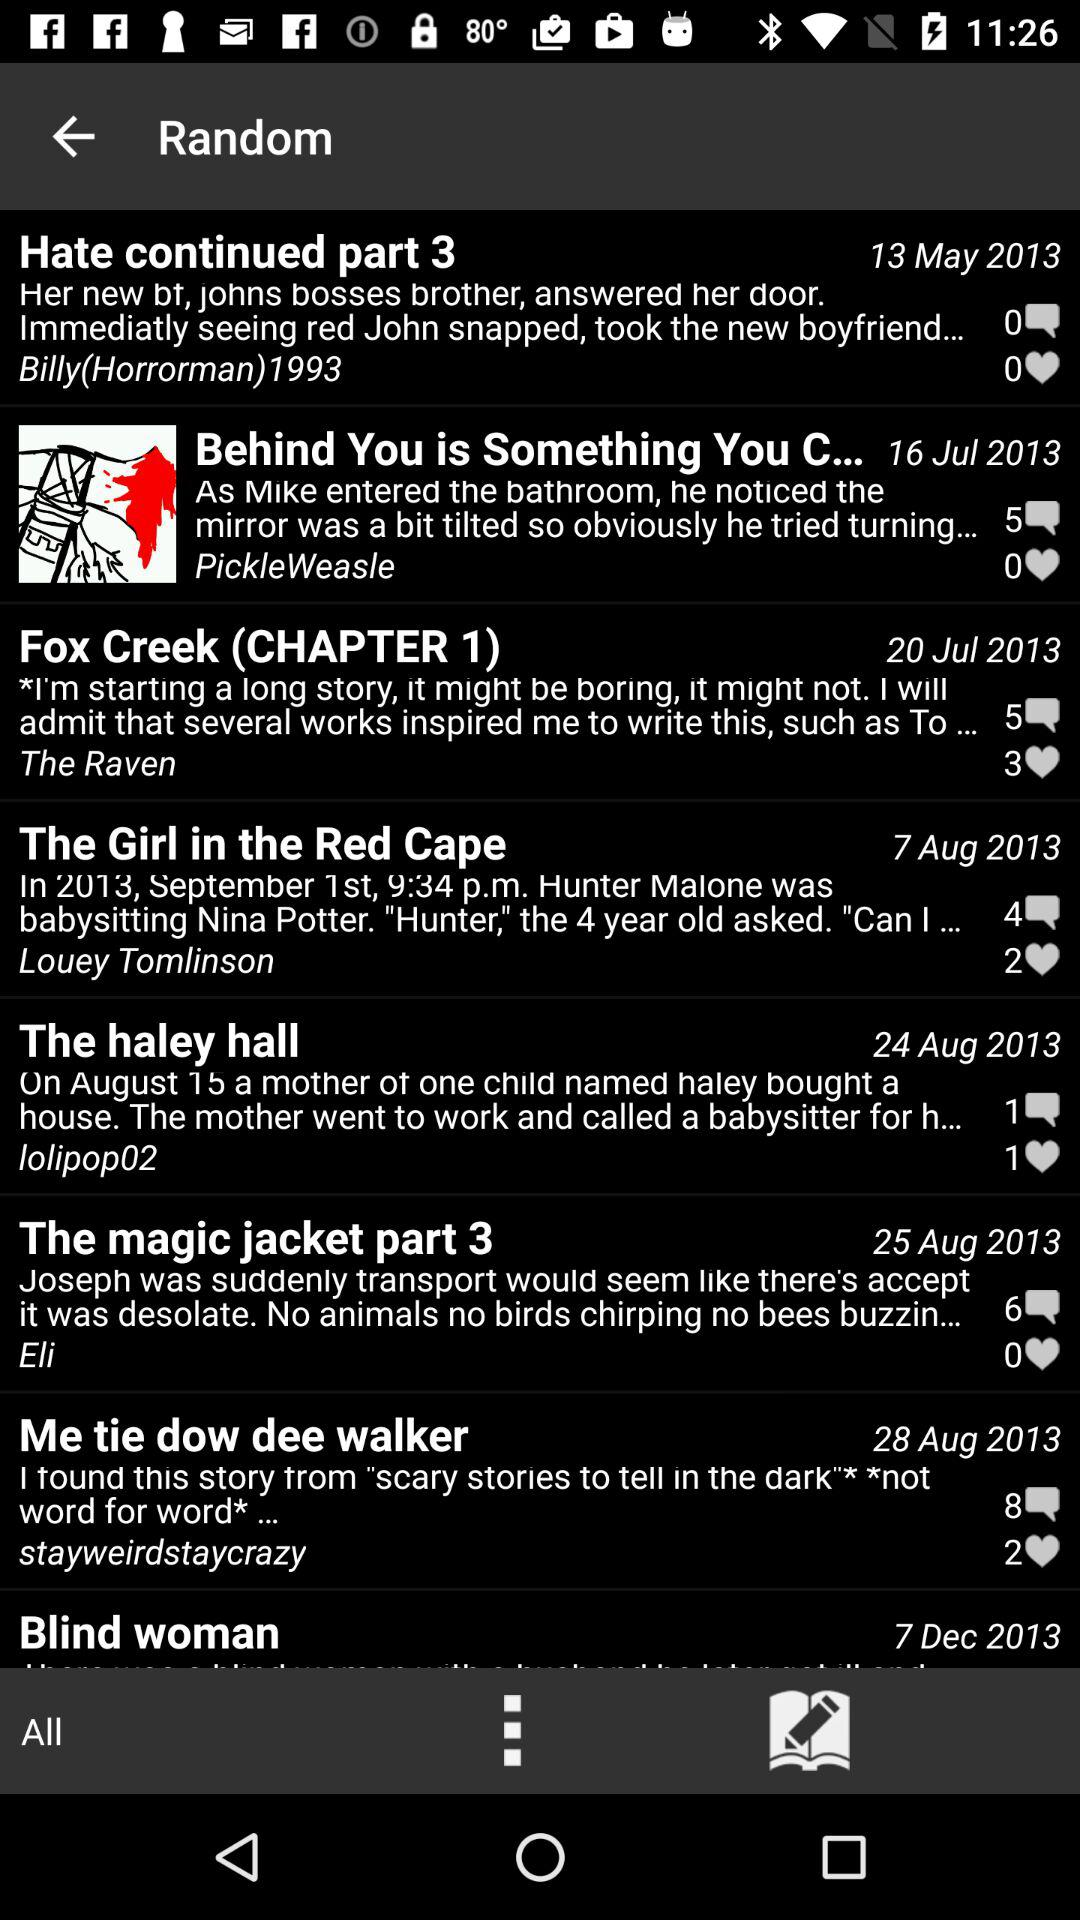Which chapter has 2 likes? The chapters "The Girl in the Red Cape" and "Me tie dow dee walker" have 2 likes. 